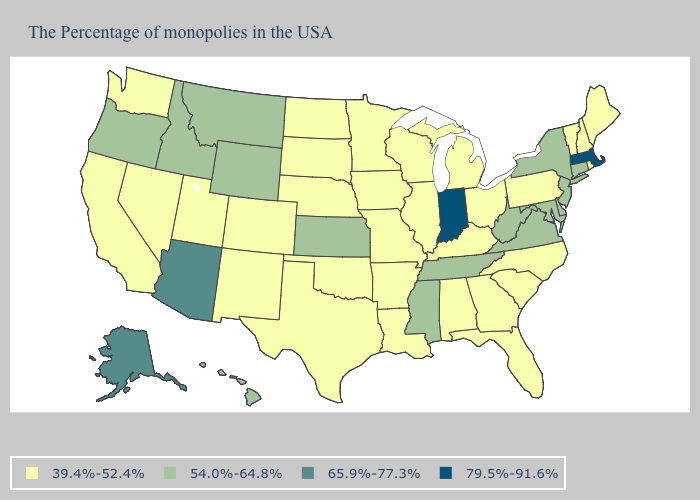What is the value of Tennessee?
Quick response, please. 54.0%-64.8%. Does Missouri have the lowest value in the MidWest?
Concise answer only. Yes. What is the value of California?
Be succinct. 39.4%-52.4%. Among the states that border Washington , which have the lowest value?
Quick response, please. Idaho, Oregon. Which states hav the highest value in the Northeast?
Short answer required. Massachusetts. Which states have the lowest value in the USA?
Short answer required. Maine, Rhode Island, New Hampshire, Vermont, Pennsylvania, North Carolina, South Carolina, Ohio, Florida, Georgia, Michigan, Kentucky, Alabama, Wisconsin, Illinois, Louisiana, Missouri, Arkansas, Minnesota, Iowa, Nebraska, Oklahoma, Texas, South Dakota, North Dakota, Colorado, New Mexico, Utah, Nevada, California, Washington. Name the states that have a value in the range 54.0%-64.8%?
Keep it brief. Connecticut, New York, New Jersey, Delaware, Maryland, Virginia, West Virginia, Tennessee, Mississippi, Kansas, Wyoming, Montana, Idaho, Oregon, Hawaii. What is the lowest value in states that border Kentucky?
Concise answer only. 39.4%-52.4%. What is the lowest value in the USA?
Give a very brief answer. 39.4%-52.4%. What is the value of Maryland?
Quick response, please. 54.0%-64.8%. Which states have the lowest value in the South?
Short answer required. North Carolina, South Carolina, Florida, Georgia, Kentucky, Alabama, Louisiana, Arkansas, Oklahoma, Texas. Does Maine have the lowest value in the Northeast?
Answer briefly. Yes. What is the highest value in states that border South Carolina?
Keep it brief. 39.4%-52.4%. What is the highest value in states that border West Virginia?
Concise answer only. 54.0%-64.8%. 